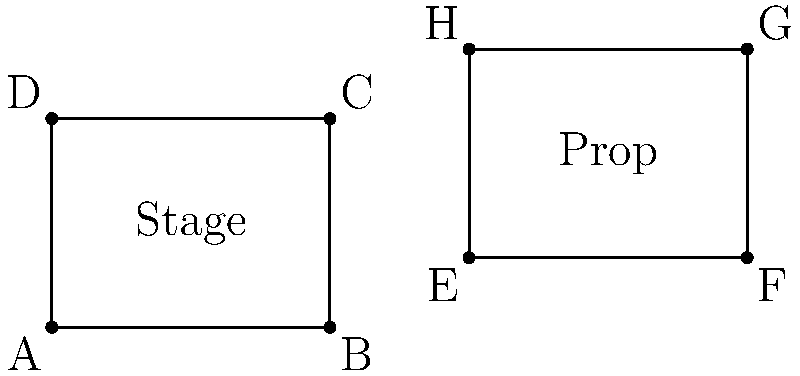In a simple set design layout, a rectangular stage is represented by points A(0,0), B(4,0), C(4,3), and D(0,3). A rectangular prop needs to be placed on the stage. The prop is currently located at E(6,1), F(10,1), G(10,4), and H(6,4). What translation vector is required to move the prop so that point E coincides with point B on the stage? To find the translation vector, we need to follow these steps:

1. Identify the current position of point E: E(6,1)
2. Identify the desired position for point E, which is point B: B(4,0)
3. Calculate the difference between the desired and current positions:
   
   Translation vector = Desired position - Current position
   
   $x$ component: $4 - 6 = -2$
   $y$ component: $0 - 1 = -1$

4. Express the translation vector in the form $(x,y)$:
   
   Translation vector = $(-2,-1)$

This vector represents the movement required to shift the prop so that point E aligns with point B on the stage. The negative values indicate that the prop needs to move 2 units left in the x-direction and 1 unit down in the y-direction.
Answer: $(-2,-1)$ 